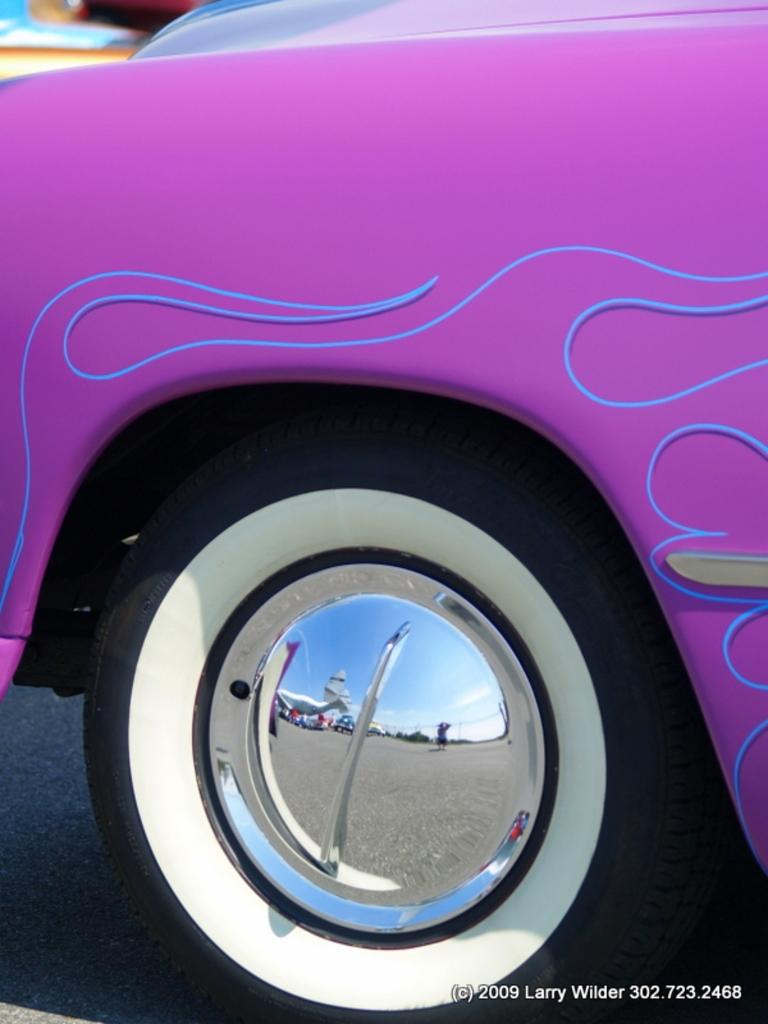What type of object is shown in the image? The image shows a part of a vehicle. Which specific part of the vehicle can be seen? There is a tyre visible in the image. What is the color of the vehicle? The vehicle is pink in color. What type of lunch is being served in the vehicle in the image? There is no lunch visible in the image, as it only shows a part of a vehicle with a tyre. Is there a note attached to the tyre in the image? There is no note present in the image; it only shows a pink vehicle with a tyre. 